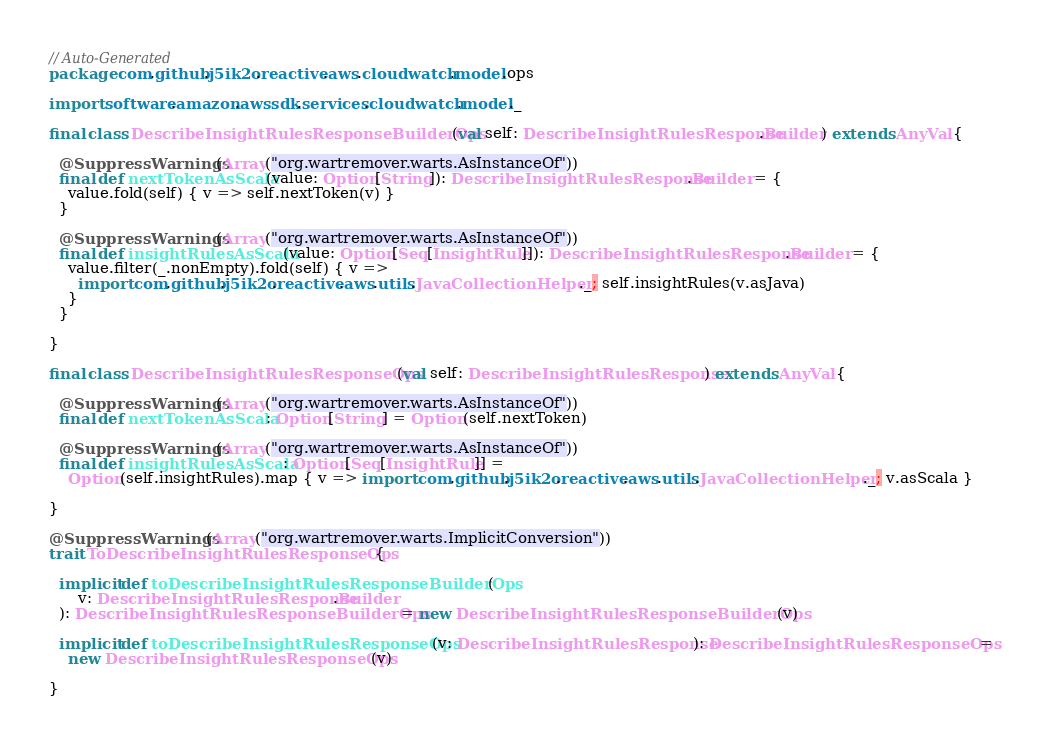Convert code to text. <code><loc_0><loc_0><loc_500><loc_500><_Scala_>// Auto-Generated
package com.github.j5ik2o.reactive.aws.cloudwatch.model.ops

import software.amazon.awssdk.services.cloudwatch.model._

final class DescribeInsightRulesResponseBuilderOps(val self: DescribeInsightRulesResponse.Builder) extends AnyVal {

  @SuppressWarnings(Array("org.wartremover.warts.AsInstanceOf"))
  final def nextTokenAsScala(value: Option[String]): DescribeInsightRulesResponse.Builder = {
    value.fold(self) { v => self.nextToken(v) }
  }

  @SuppressWarnings(Array("org.wartremover.warts.AsInstanceOf"))
  final def insightRulesAsScala(value: Option[Seq[InsightRule]]): DescribeInsightRulesResponse.Builder = {
    value.filter(_.nonEmpty).fold(self) { v =>
      import com.github.j5ik2o.reactive.aws.utils.JavaCollectionHelper._; self.insightRules(v.asJava)
    }
  }

}

final class DescribeInsightRulesResponseOps(val self: DescribeInsightRulesResponse) extends AnyVal {

  @SuppressWarnings(Array("org.wartremover.warts.AsInstanceOf"))
  final def nextTokenAsScala: Option[String] = Option(self.nextToken)

  @SuppressWarnings(Array("org.wartremover.warts.AsInstanceOf"))
  final def insightRulesAsScala: Option[Seq[InsightRule]] =
    Option(self.insightRules).map { v => import com.github.j5ik2o.reactive.aws.utils.JavaCollectionHelper._; v.asScala }

}

@SuppressWarnings(Array("org.wartremover.warts.ImplicitConversion"))
trait ToDescribeInsightRulesResponseOps {

  implicit def toDescribeInsightRulesResponseBuilderOps(
      v: DescribeInsightRulesResponse.Builder
  ): DescribeInsightRulesResponseBuilderOps = new DescribeInsightRulesResponseBuilderOps(v)

  implicit def toDescribeInsightRulesResponseOps(v: DescribeInsightRulesResponse): DescribeInsightRulesResponseOps =
    new DescribeInsightRulesResponseOps(v)

}
</code> 